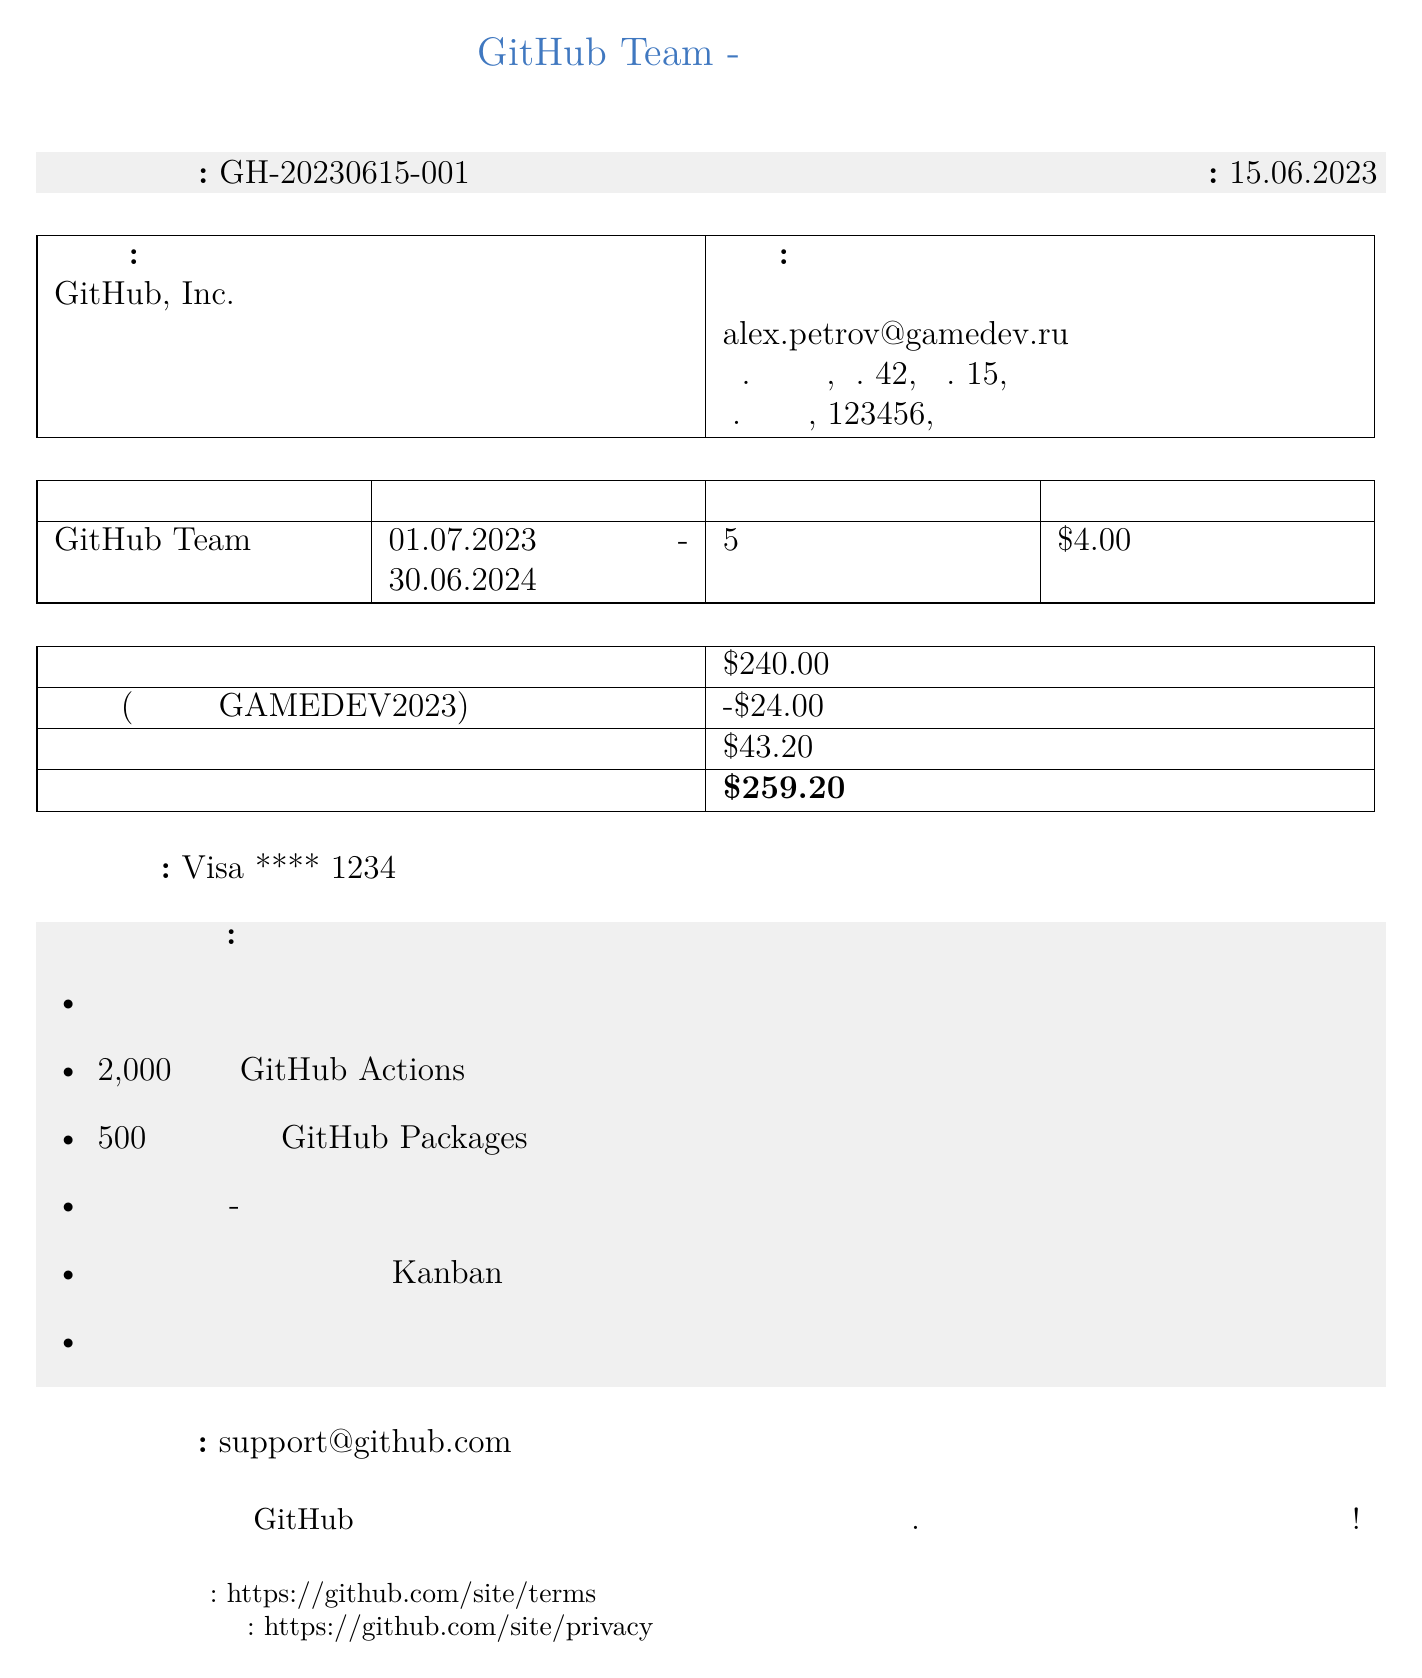Что представляет собой продукт? Продукт указан в документе как "GitHub Team".
Answer: GitHub Team Какой срок подписки? В документе указано, что срок подписки составляет с 01.07.2023 по 30.06.2024.
Answer: 01.07.2023 - 30.06.2024 Сколько пользователей включено в подписку? В документе указано количество пользователей, равное 5.
Answer: 5 Какова общая сумма к оплате? Сумма к оплате указана внизу документа и составляет 259.20 долларов.
Answer: 259.20 Какая скидка была применена? Скидка в документе указана как 24 доллара, примененная при использовании промокода.
Answer: -24.00 Какой контакт для поддержки? Документ предоставляет контактный адрес службы поддержки для обращений.
Answer: support@github.com Какой способ оплаты используется? В чеке указан способ оплаты с картой Visa.
Answer: Visa **** 1234 Какие функции входят в подписку? Включенные функции перечислены в документе и представлены в виде списка.
Answer: Неограниченные публичные и приватные репозитории, 2,000 минут GitHub Actions в месяц, 500 МБ хранилища GitHub Packages, Совместный код-ревью, Управление проектами с досками Kanban, Расширенные инструменты для совместной работы команды 